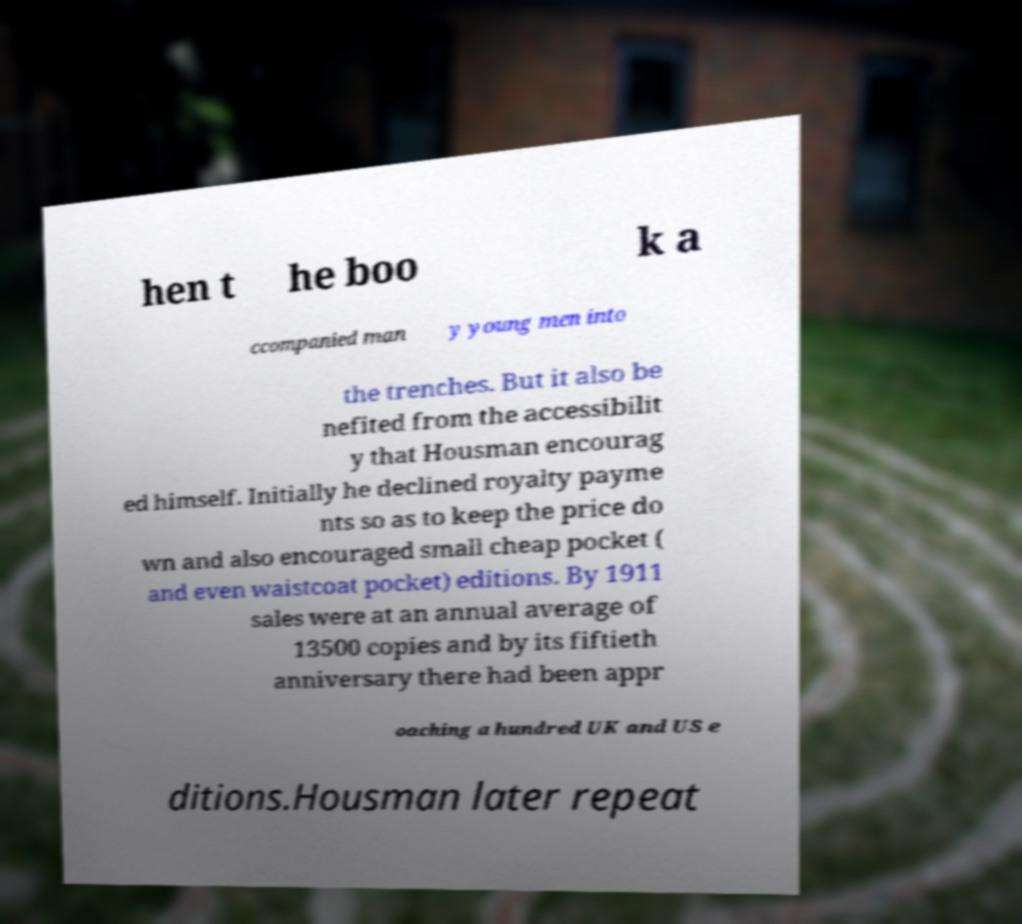Could you assist in decoding the text presented in this image and type it out clearly? hen t he boo k a ccompanied man y young men into the trenches. But it also be nefited from the accessibilit y that Housman encourag ed himself. Initially he declined royalty payme nts so as to keep the price do wn and also encouraged small cheap pocket ( and even waistcoat pocket) editions. By 1911 sales were at an annual average of 13500 copies and by its fiftieth anniversary there had been appr oaching a hundred UK and US e ditions.Housman later repeat 